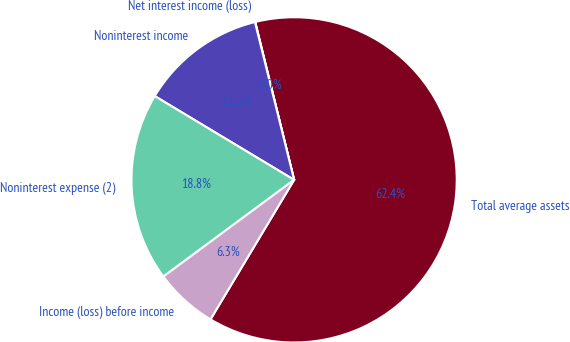<chart> <loc_0><loc_0><loc_500><loc_500><pie_chart><fcel>Total average assets<fcel>Net interest income (loss)<fcel>Noninterest income<fcel>Noninterest expense (2)<fcel>Income (loss) before income<nl><fcel>62.44%<fcel>0.03%<fcel>12.51%<fcel>18.75%<fcel>6.27%<nl></chart> 